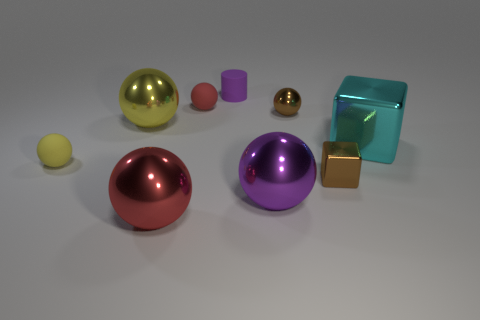Subtract all small brown balls. How many balls are left? 5 Subtract all cylinders. How many objects are left? 8 Add 1 yellow rubber objects. How many objects exist? 10 Subtract all yellow balls. How many balls are left? 4 Subtract 3 spheres. How many spheres are left? 3 Subtract all brown blocks. Subtract all yellow cylinders. How many blocks are left? 1 Subtract all gray blocks. How many yellow cylinders are left? 0 Subtract all small red cylinders. Subtract all big purple metallic objects. How many objects are left? 8 Add 4 large cyan metallic objects. How many large cyan metallic objects are left? 5 Add 8 small brown shiny cubes. How many small brown shiny cubes exist? 9 